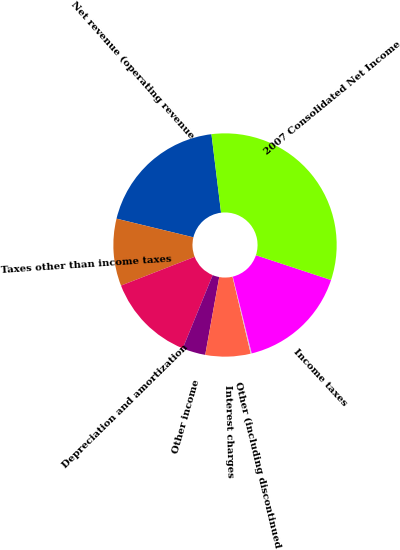Convert chart to OTSL. <chart><loc_0><loc_0><loc_500><loc_500><pie_chart><fcel>Net revenue (operating revenue<fcel>Taxes other than income taxes<fcel>Depreciation and amortization<fcel>Other income<fcel>Interest charges<fcel>Other (including discontinued<fcel>Income taxes<fcel>2007 Consolidated Net Income<nl><fcel>19.27%<fcel>9.71%<fcel>12.9%<fcel>3.34%<fcel>6.53%<fcel>0.15%<fcel>16.08%<fcel>32.01%<nl></chart> 